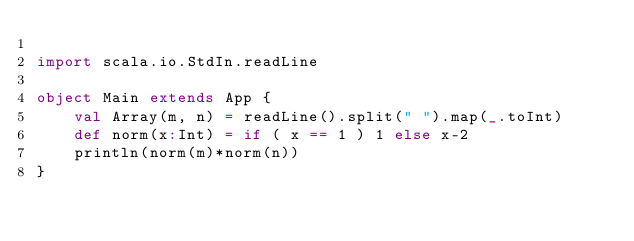Convert code to text. <code><loc_0><loc_0><loc_500><loc_500><_Scala_>
import scala.io.StdIn.readLine

object Main extends App {
	val Array(m, n) = readLine().split(" ").map(_.toInt)
	def norm(x:Int) = if ( x == 1 ) 1 else x-2
	println(norm(m)*norm(n))
}</code> 